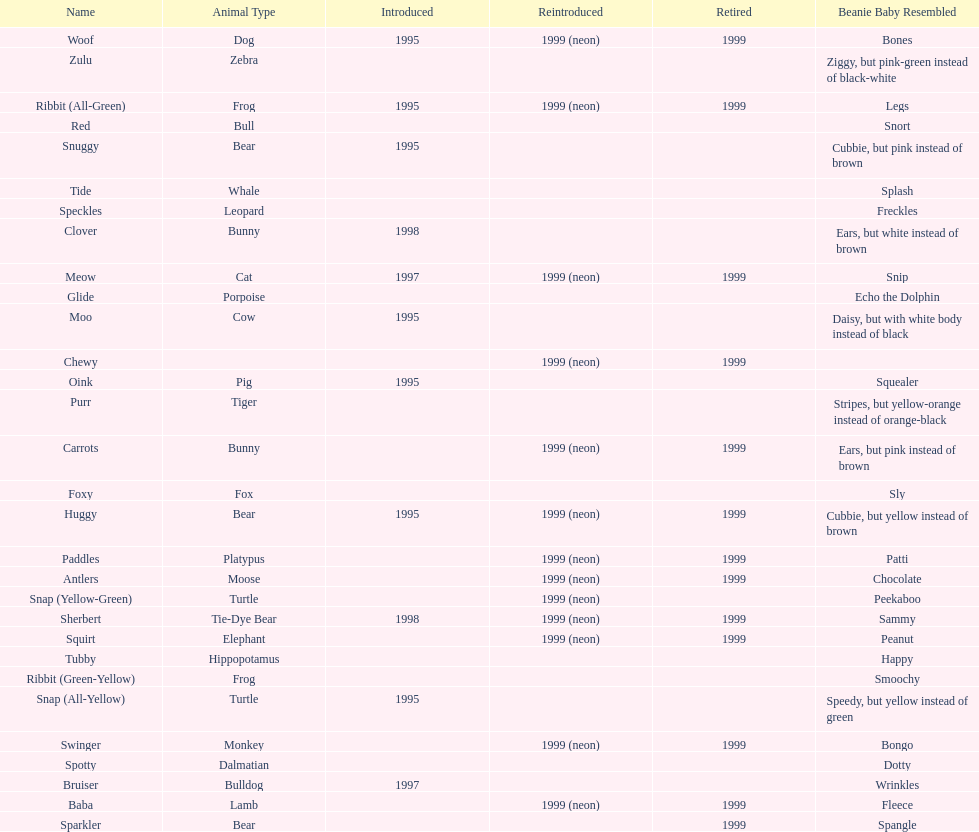How many monkey pillow pals were there? 1. 